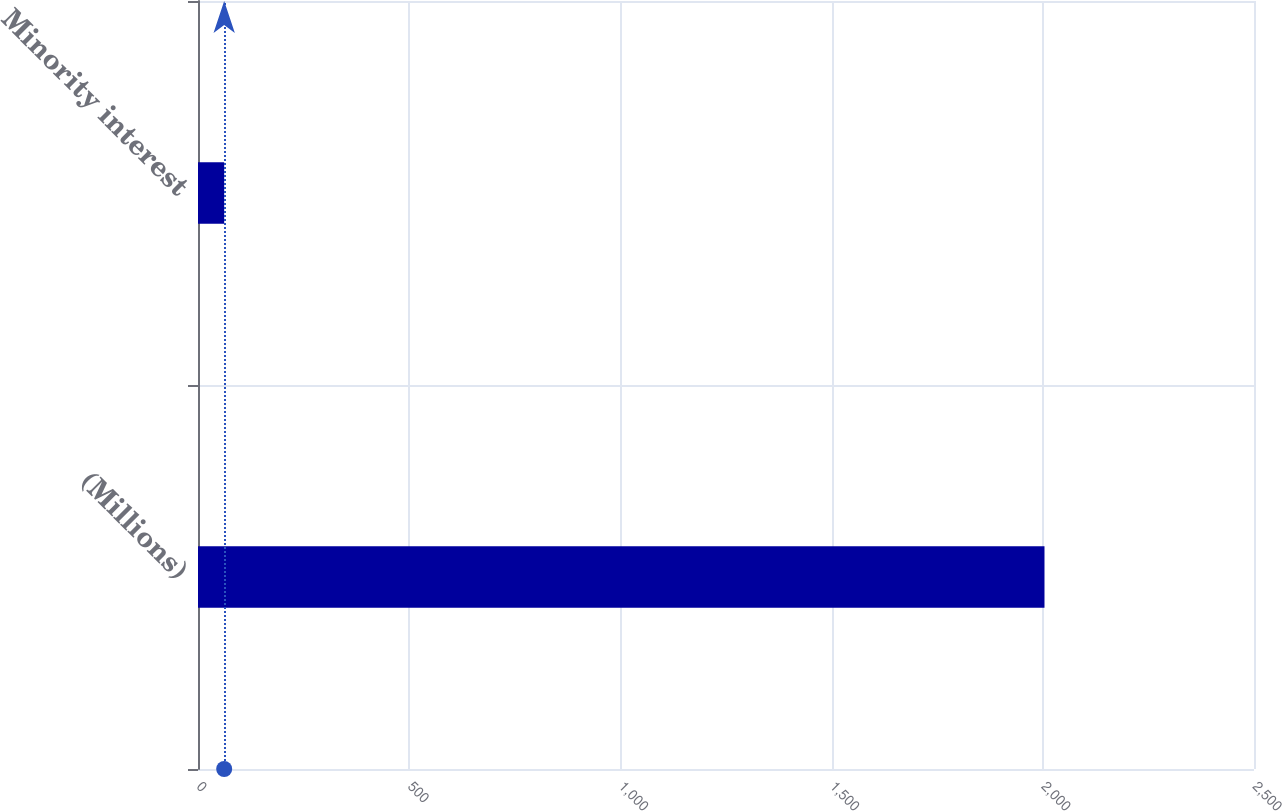<chart> <loc_0><loc_0><loc_500><loc_500><bar_chart><fcel>(Millions)<fcel>Minority interest<nl><fcel>2004<fcel>62<nl></chart> 